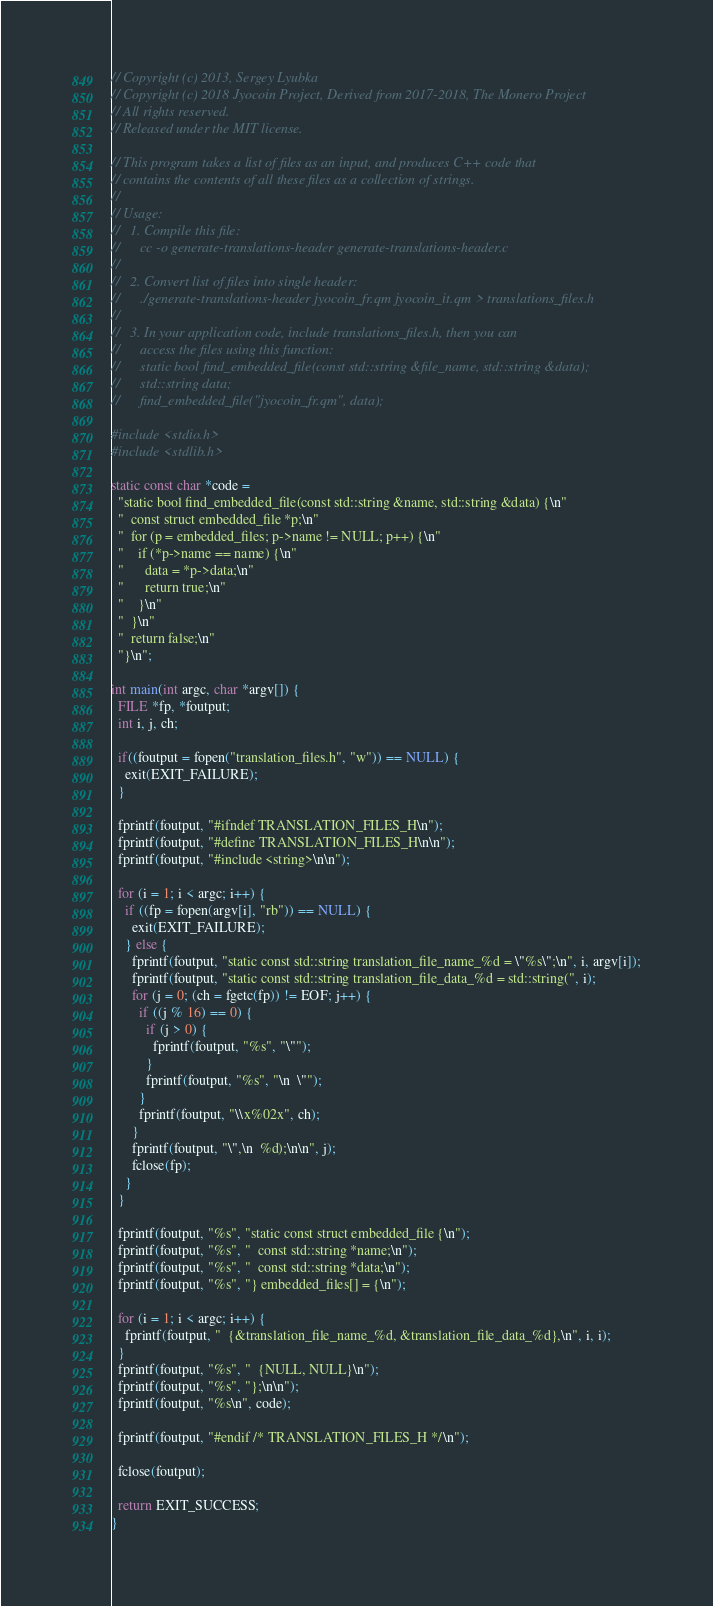Convert code to text. <code><loc_0><loc_0><loc_500><loc_500><_C_>// Copyright (c) 2013, Sergey Lyubka
// Copyright (c) 2018 Jyocoin Project, Derived from 2017-2018, The Monero Project
// All rights reserved.
// Released under the MIT license.

// This program takes a list of files as an input, and produces C++ code that
// contains the contents of all these files as a collection of strings.
//
// Usage:
//   1. Compile this file:
//      cc -o generate-translations-header generate-translations-header.c
//
//   2. Convert list of files into single header:
//      ./generate-translations-header jyocoin_fr.qm jyocoin_it.qm > translations_files.h
//
//   3. In your application code, include translations_files.h, then you can
//      access the files using this function:
//      static bool find_embedded_file(const std::string &file_name, std::string &data);
//      std::string data;
//      find_embedded_file("jyocoin_fr.qm", data);

#include <stdio.h>
#include <stdlib.h>

static const char *code =
  "static bool find_embedded_file(const std::string &name, std::string &data) {\n"
  "  const struct embedded_file *p;\n"
  "  for (p = embedded_files; p->name != NULL; p++) {\n"
  "    if (*p->name == name) {\n"
  "      data = *p->data;\n"
  "      return true;\n"
  "    }\n"
  "  }\n"
  "  return false;\n"
  "}\n";

int main(int argc, char *argv[]) {
  FILE *fp, *foutput;
  int i, j, ch;

  if((foutput = fopen("translation_files.h", "w")) == NULL) {
    exit(EXIT_FAILURE);
  }

  fprintf(foutput, "#ifndef TRANSLATION_FILES_H\n");
  fprintf(foutput, "#define TRANSLATION_FILES_H\n\n");
  fprintf(foutput, "#include <string>\n\n");

  for (i = 1; i < argc; i++) {
    if ((fp = fopen(argv[i], "rb")) == NULL) {
      exit(EXIT_FAILURE);
    } else {
      fprintf(foutput, "static const std::string translation_file_name_%d = \"%s\";\n", i, argv[i]);
      fprintf(foutput, "static const std::string translation_file_data_%d = std::string(", i);
      for (j = 0; (ch = fgetc(fp)) != EOF; j++) {
        if ((j % 16) == 0) {
          if (j > 0) {
            fprintf(foutput, "%s", "\"");
          }
          fprintf(foutput, "%s", "\n  \"");
        }
        fprintf(foutput, "\\x%02x", ch);
      }
      fprintf(foutput, "\",\n  %d);\n\n", j);
      fclose(fp);
    }
  }

  fprintf(foutput, "%s", "static const struct embedded_file {\n");
  fprintf(foutput, "%s", "  const std::string *name;\n");
  fprintf(foutput, "%s", "  const std::string *data;\n");
  fprintf(foutput, "%s", "} embedded_files[] = {\n");

  for (i = 1; i < argc; i++) {
    fprintf(foutput, "  {&translation_file_name_%d, &translation_file_data_%d},\n", i, i);
  }
  fprintf(foutput, "%s", "  {NULL, NULL}\n");
  fprintf(foutput, "%s", "};\n\n");
  fprintf(foutput, "%s\n", code);

  fprintf(foutput, "#endif /* TRANSLATION_FILES_H */\n");

  fclose(foutput);

  return EXIT_SUCCESS;
}
</code> 